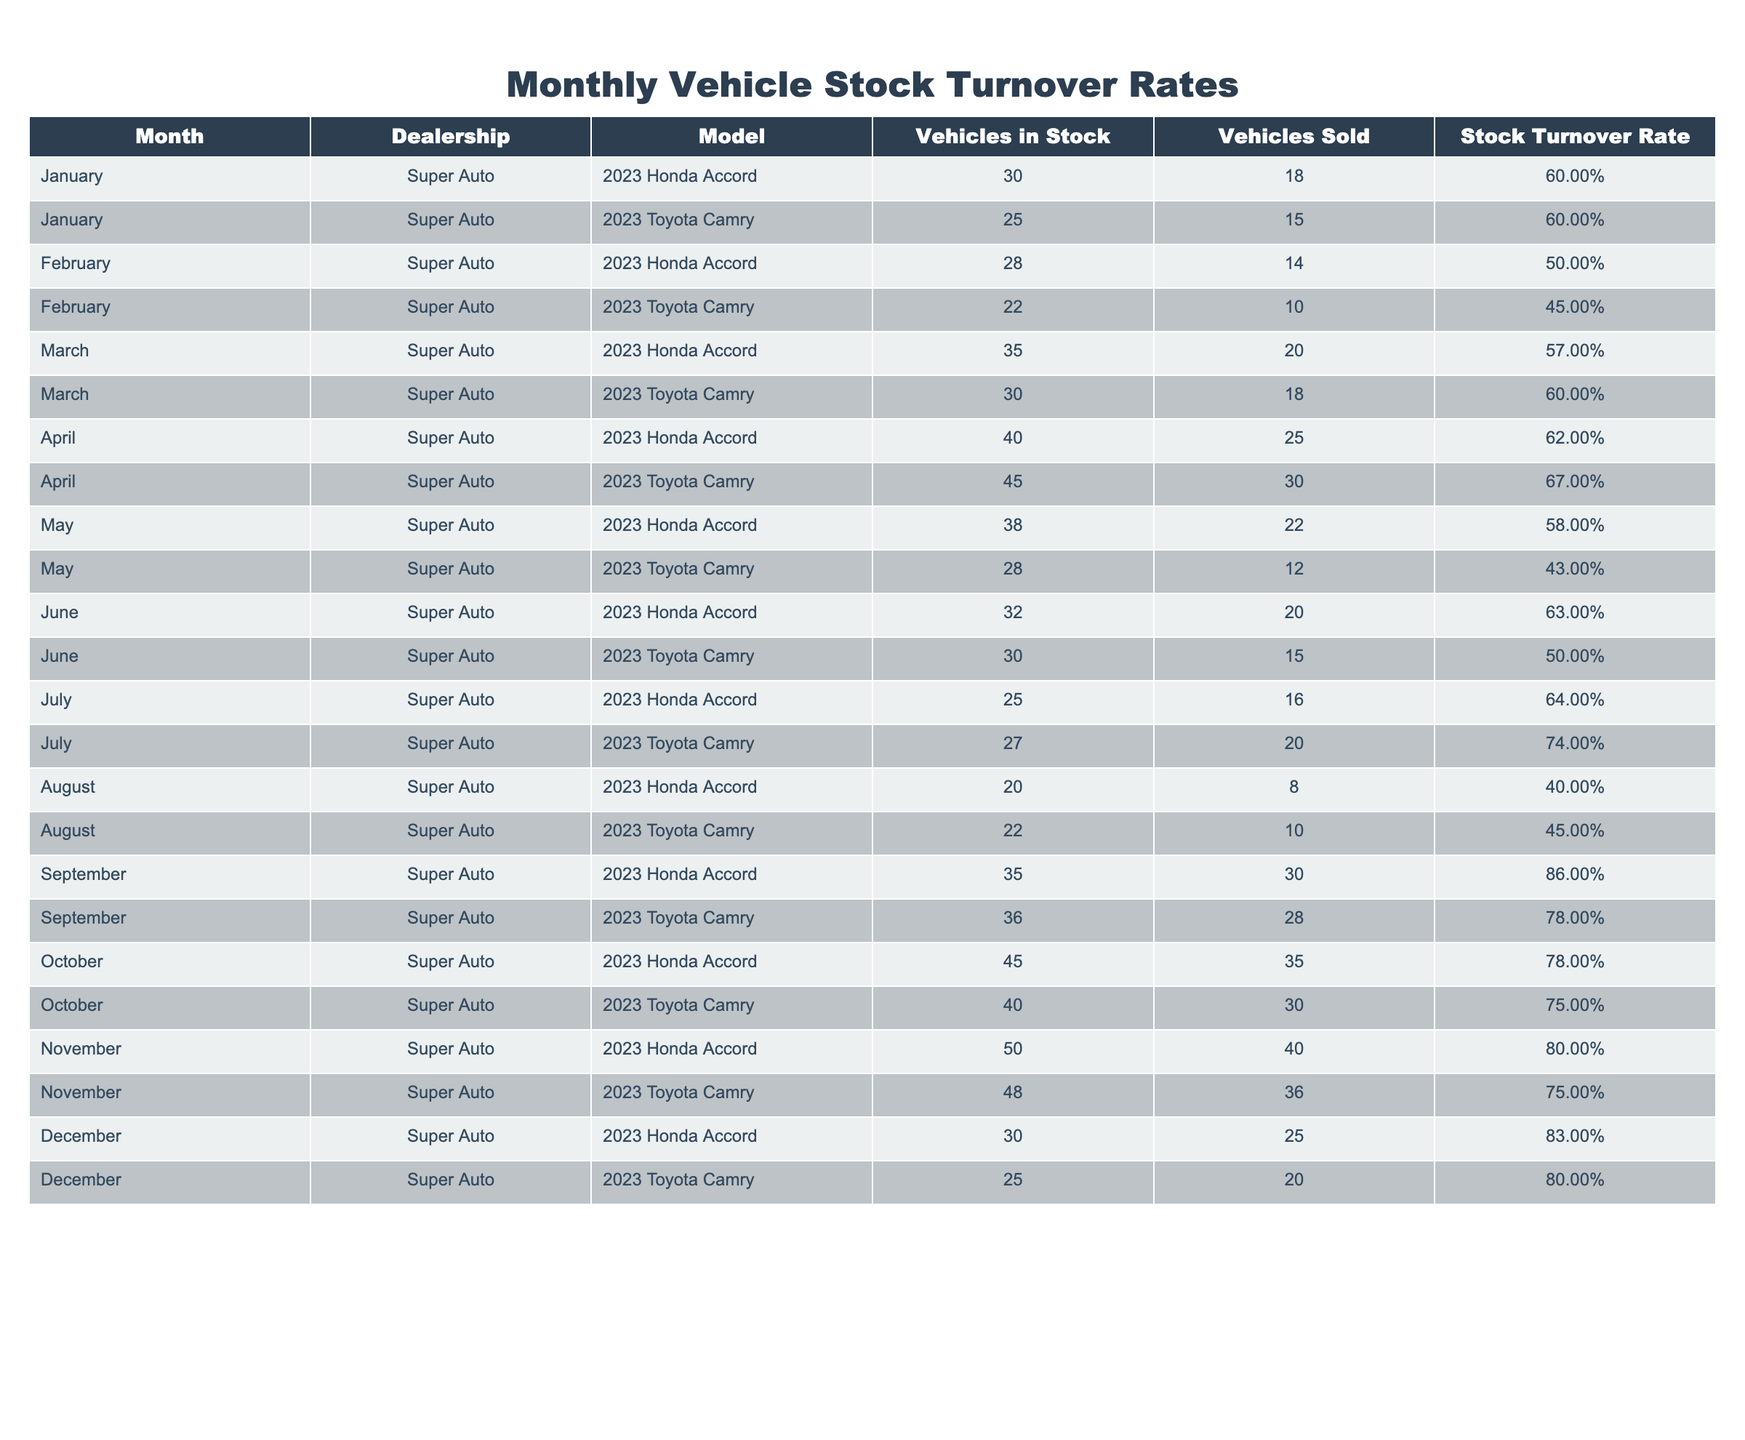What was the highest stock turnover rate for the Honda Accord? From the table data, the highest stock turnover rate for the Honda Accord is found in September, which is 0.86.
Answer: 0.86 What month had the lowest stock turnover rate for the Toyota Camry? Looking at the Toyota Camry data, the lowest stock turnover rate occurs in May with a value of 0.43.
Answer: 0.43 What is the average stock turnover rate for the Honda Accord from January to December? To find the average, sum the stock turnover rates for each month: 0.60 + 0.50 + 0.57 + 0.62 + 0.58 + 0.63 + 0.64 + 0.40 + 0.86 + 0.78 + 0.80 + 0.83 = 7.23. There are 12 months, so 7.23 / 12 = 0.6025. Rounded to two decimal places, the average is approximately 0.60.
Answer: 0.60 Did the stock turnover rate for the Toyota Camry ever exceed 0.70? By reviewing the table, we see that in July, the stock turnover rate for the Toyota Camry reached 0.74, which is above 0.70. Therefore, the statement is true.
Answer: Yes In which month did the total number of vehicles sold for the Honda Accord exceed 20? By checking the vehicles sold for each month, we see that in March (20), April (25), September (30), October (35), and November (40) the number of sold vehicles exceeded 20. Therefore, the notable months are March, April, September, October, and November.
Answer: March, April, September, October, November 